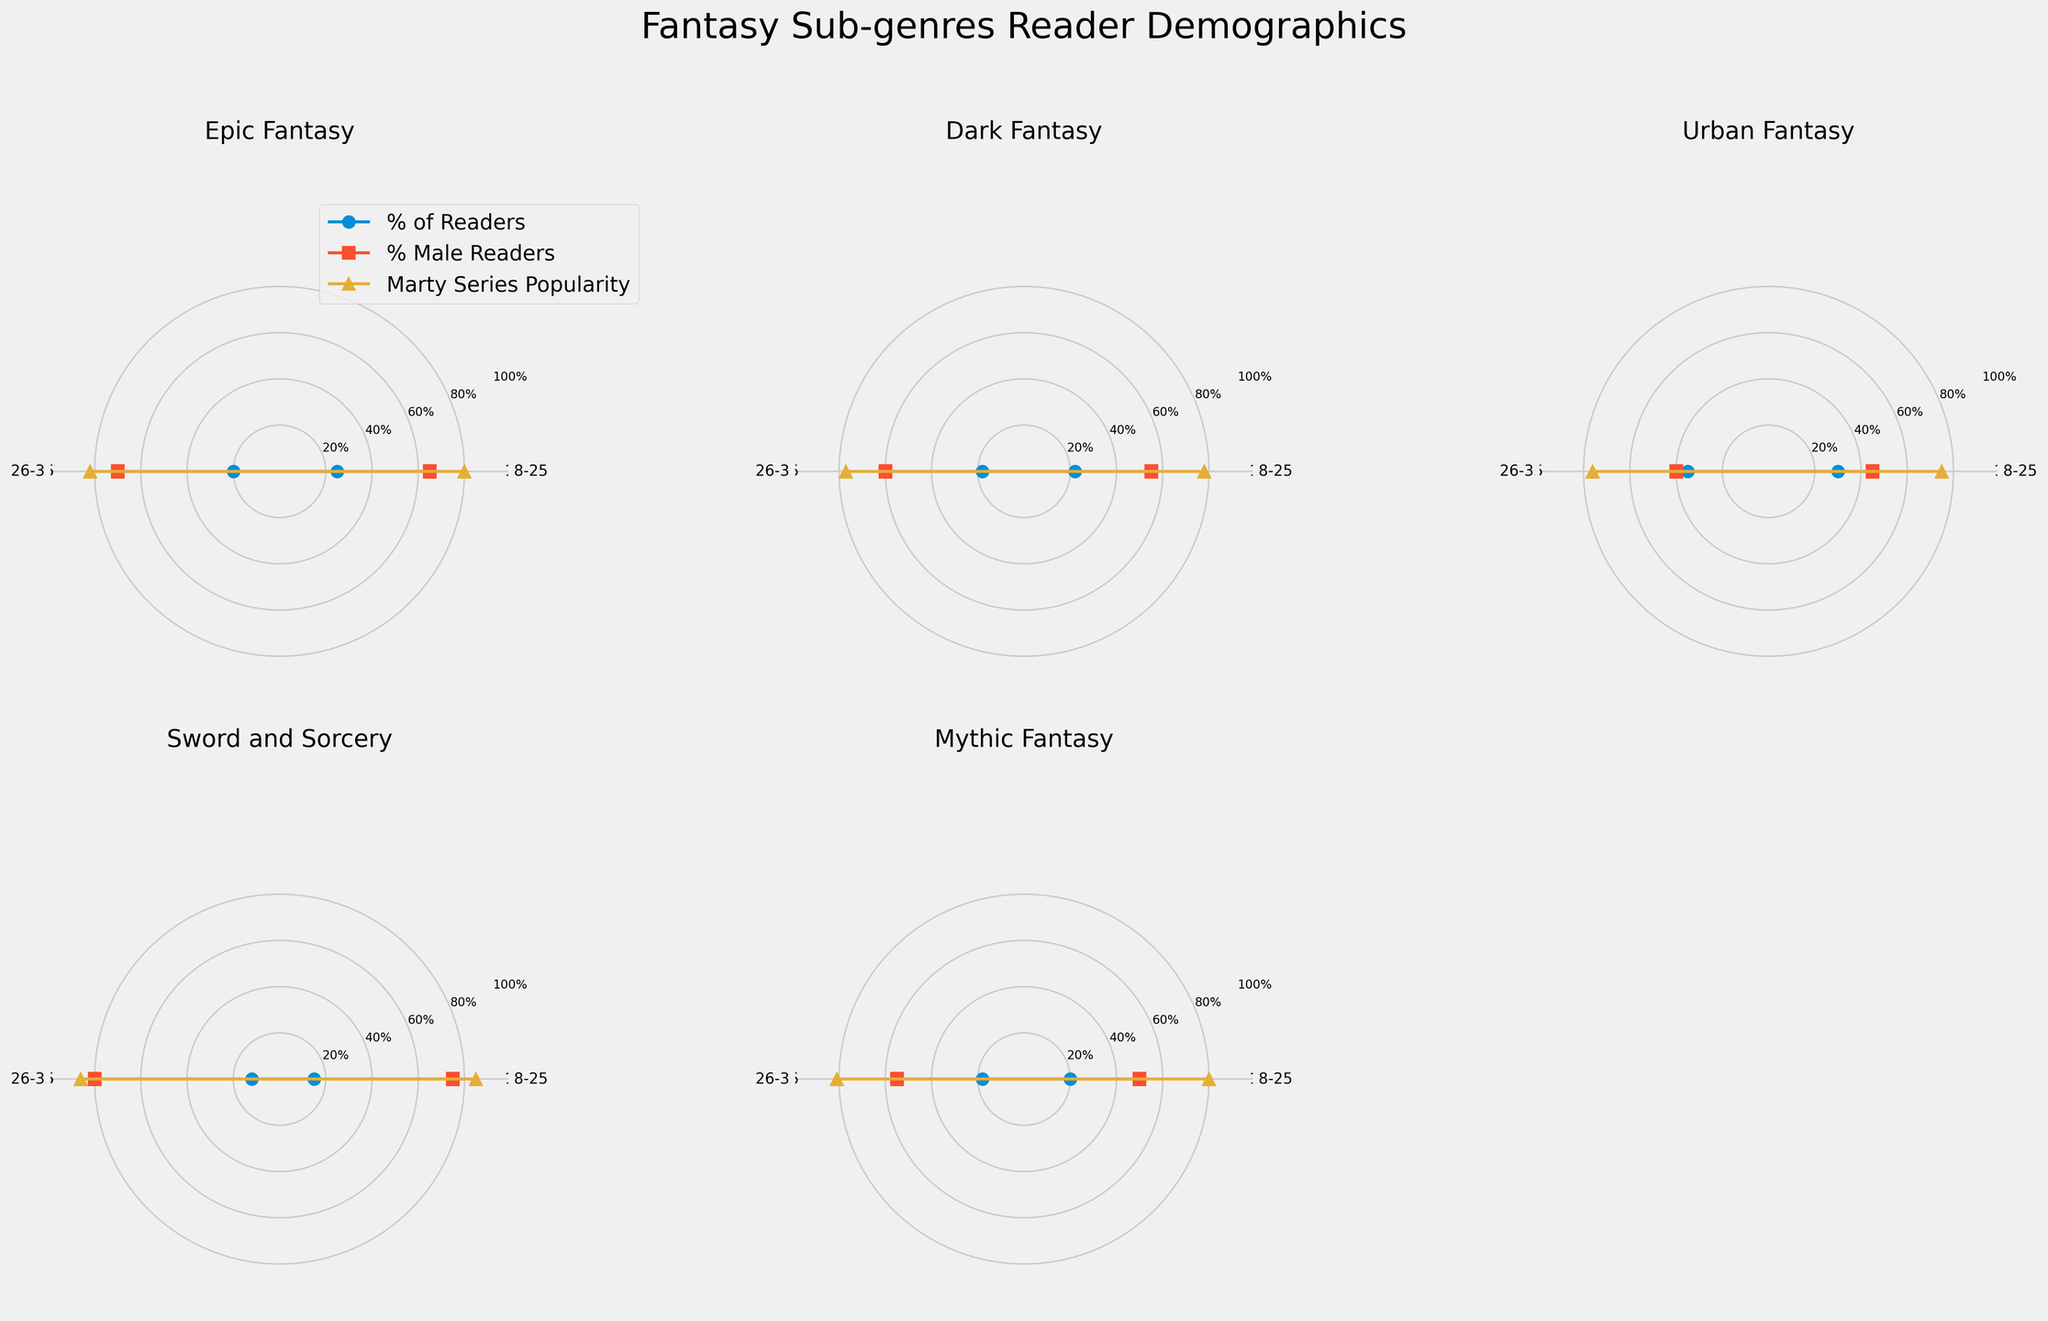What is the title of the figure? The title is usually found at the top of the figure and gives a summary of what is being presented. In this case, it should be clear and descriptive of the content.
Answer: Fantasy Sub-genres Reader Demographics Which sub-genre has the highest percentage of readers in the 18-25 age group? Look at the 'Percentage of Readers' line for each sub-plot, corresponding to the 18-25 age group, and identify which has the highest value.
Answer: Urban Fantasy What is the gender distribution of readers for Sword and Sorcery in the 26-35 age group? In the Sword and Sorcery sub-plot, look at the section for 26-35 age group and identify the values for male and female percentages.
Answer: Male 80% Female 20% Which age group has the highest popularity rating for the Marty Series in Epic Fantasy? Check the 'Marty Series Popularity Rating' for each age group in the Epic Fantasy sub-plot and compare the values.
Answer: 26-35 Is there a sub-genre where the percentage of female readers is higher than male readers? Look across all sub-plots and compare the gender distribution for all age groups to find where female percentage is higher.
Answer: Yes, Urban Fantasy for both age groups In Dark Fantasy, how does the percentage of readers change between the 18-25 and 26-35 age groups? Note the 'Percentage of Readers' line in the Dark Fantasy sub-plot for both age groups and calculate the difference.
Answer: Decreases by 4% Which sub-genre has the least difference in Marty Series Popularity Rating between the two age groups? Compare the Marty Series Popularity Ratings for both age groups across all sub-genres and find the smallest difference.
Answer: Dark Fantasy What trend do you observe in the gender distribution for Mythic Fantasy between the two age groups? Compare the male and female percentages between 18-25 and 26-35 age groups in the Mythic Fantasy sub-plot for visible trends.
Answer: Increase in male percentage by 5% Which sub-genre shows the highest percentage of readers for the 26-35 age group? Look at the 'Percentage of Readers' line for each sub-plot corresponding to the 26-35 age group and identify the highest value.
Answer: Urban Fantasy How does the popularity rating of the Marty Series compare between Sword and Sorcery and Urban Fantasy in the 18-25 age group? Look at the Marty Series Popularity Ratings for both sub-genres in the 18-25 age group and compare the values to see which is higher.
Answer: Sword and Sorcery is higher 